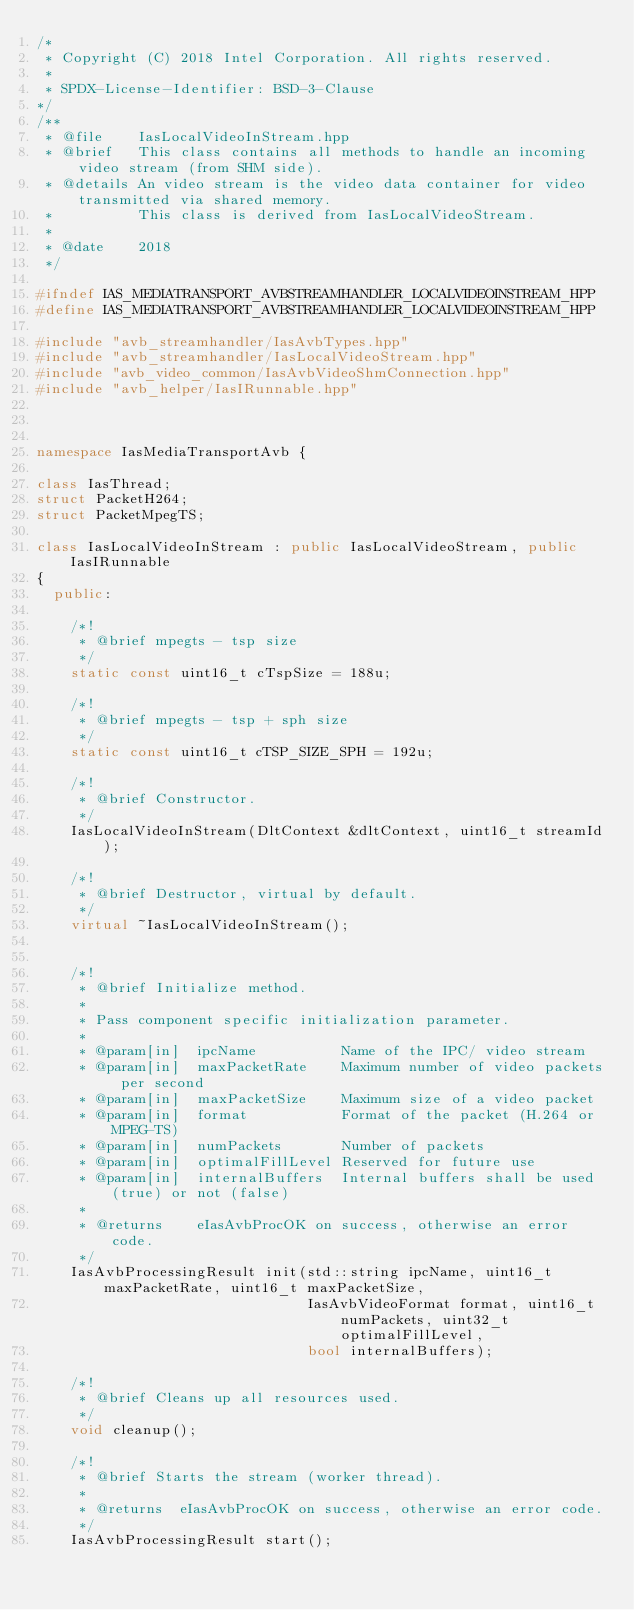<code> <loc_0><loc_0><loc_500><loc_500><_C++_>/*
 * Copyright (C) 2018 Intel Corporation. All rights reserved.
 *
 * SPDX-License-Identifier: BSD-3-Clause
*/
/**
 * @file    IasLocalVideoInStream.hpp
 * @brief   This class contains all methods to handle an incoming video stream (from SHM side).
 * @details An video stream is the video data container for video transmitted via shared memory.
 *          This class is derived from IasLocalVideoStream.
 *
 * @date    2018
 */

#ifndef IAS_MEDIATRANSPORT_AVBSTREAMHANDLER_LOCALVIDEOINSTREAM_HPP
#define IAS_MEDIATRANSPORT_AVBSTREAMHANDLER_LOCALVIDEOINSTREAM_HPP

#include "avb_streamhandler/IasAvbTypes.hpp"
#include "avb_streamhandler/IasLocalVideoStream.hpp"
#include "avb_video_common/IasAvbVideoShmConnection.hpp"
#include "avb_helper/IasIRunnable.hpp"



namespace IasMediaTransportAvb {

class IasThread;
struct PacketH264;
struct PacketMpegTS;

class IasLocalVideoInStream : public IasLocalVideoStream, public IasIRunnable
{
  public:

    /*!
     * @brief mpegts - tsp size
     */
    static const uint16_t cTspSize = 188u;

    /*!
     * @brief mpegts - tsp + sph size
     */
    static const uint16_t cTSP_SIZE_SPH = 192u;

    /*!
     * @brief Constructor.
     */
    IasLocalVideoInStream(DltContext &dltContext, uint16_t streamId);

    /*!
     * @brief Destructor, virtual by default.
     */
    virtual ~IasLocalVideoInStream();


    /*!
     * @brief Initialize method.
     *
     * Pass component specific initialization parameter.
     *
     * @param[in]  ipcName          Name of the IPC/ video stream
     * @param[in]  maxPacketRate    Maximum number of video packets per second
     * @param[in]  maxPacketSize    Maximum size of a video packet
     * @param[in]  format           Format of the packet (H.264 or MPEG-TS)
     * @param[in]  numPackets       Number of packets
     * @param[in]  optimalFillLevel Reserved for future use
     * @param[in]  internalBuffers  Internal buffers shall be used (true) or not (false)
     *
     * @returns    eIasAvbProcOK on success, otherwise an error code.
     */
    IasAvbProcessingResult init(std::string ipcName, uint16_t maxPacketRate, uint16_t maxPacketSize,
                                IasAvbVideoFormat format, uint16_t numPackets, uint32_t optimalFillLevel,
                                bool internalBuffers);

    /*!
     * @brief Cleans up all resources used.
     */
    void cleanup();

    /*!
     * @brief Starts the stream (worker thread).
     *
     * @returns  eIasAvbProcOK on success, otherwise an error code.
     */
    IasAvbProcessingResult start();
</code> 